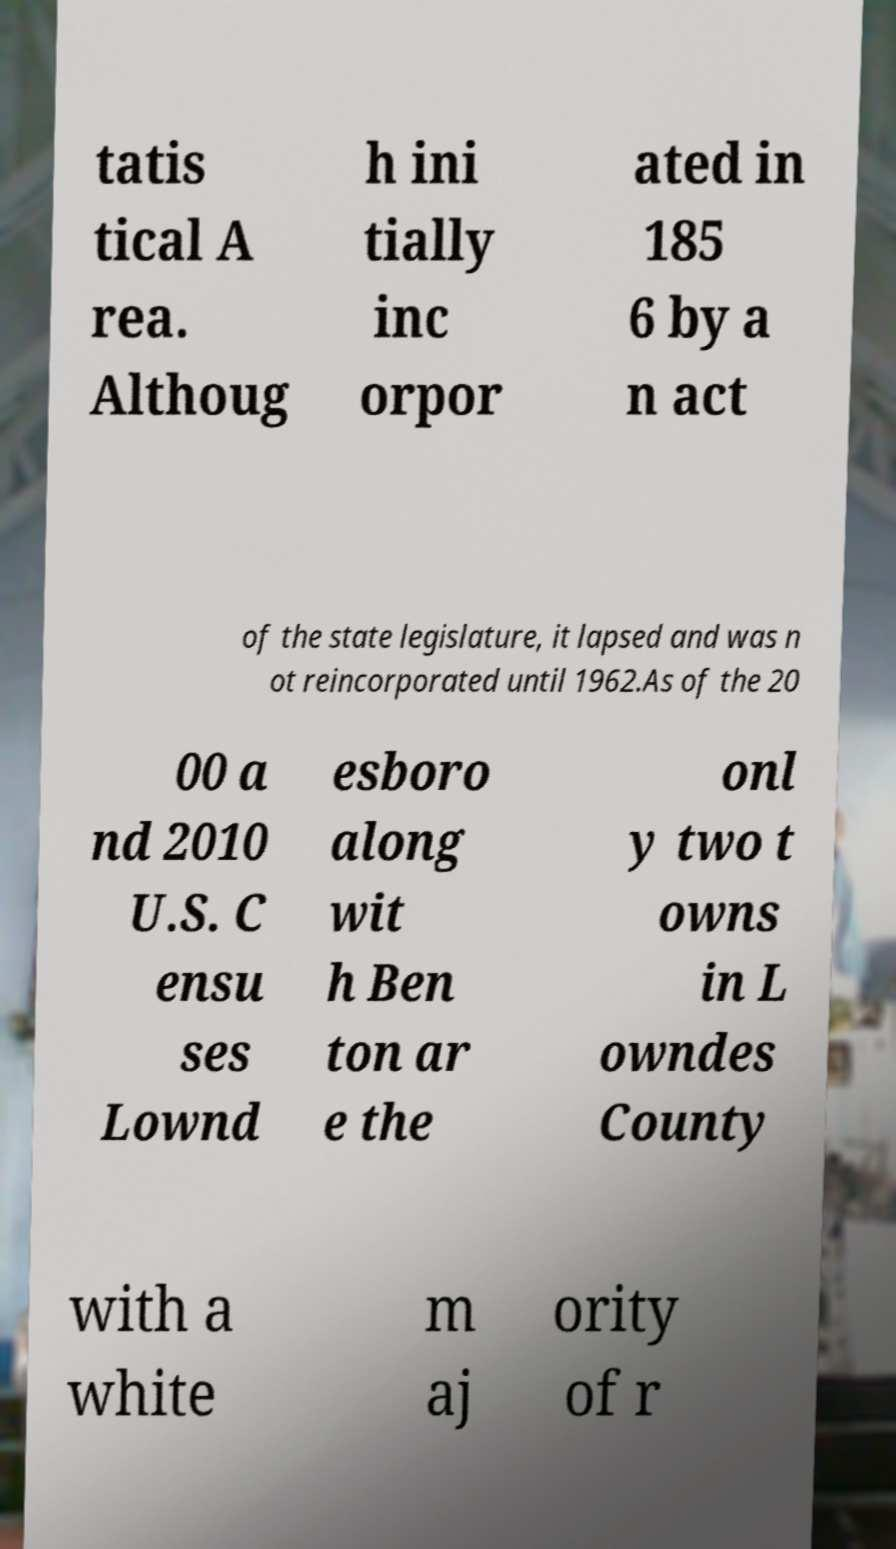Could you extract and type out the text from this image? tatis tical A rea. Althoug h ini tially inc orpor ated in 185 6 by a n act of the state legislature, it lapsed and was n ot reincorporated until 1962.As of the 20 00 a nd 2010 U.S. C ensu ses Lownd esboro along wit h Ben ton ar e the onl y two t owns in L owndes County with a white m aj ority of r 